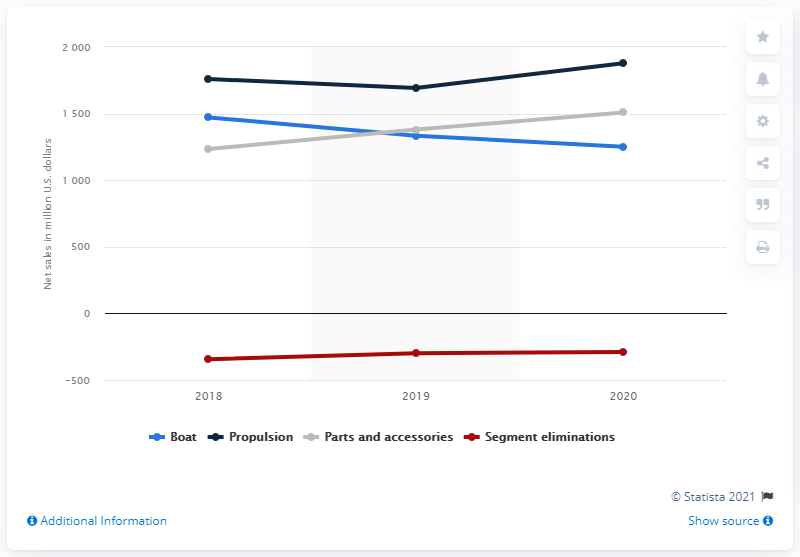List a handful of essential elements in this visual. In 2020, the revenue for the boat segment was 1,250.3 million. 